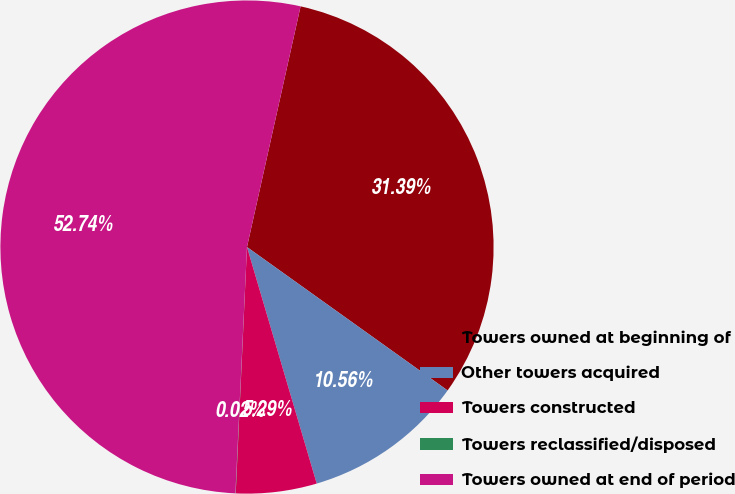<chart> <loc_0><loc_0><loc_500><loc_500><pie_chart><fcel>Towers owned at beginning of<fcel>Other towers acquired<fcel>Towers constructed<fcel>Towers reclassified/disposed<fcel>Towers owned at end of period<nl><fcel>31.39%<fcel>10.56%<fcel>5.29%<fcel>0.02%<fcel>52.74%<nl></chart> 